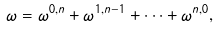Convert formula to latex. <formula><loc_0><loc_0><loc_500><loc_500>\omega = \omega ^ { 0 , n } + \omega ^ { 1 , n - 1 } + \dots + \omega ^ { n , 0 } ,</formula> 